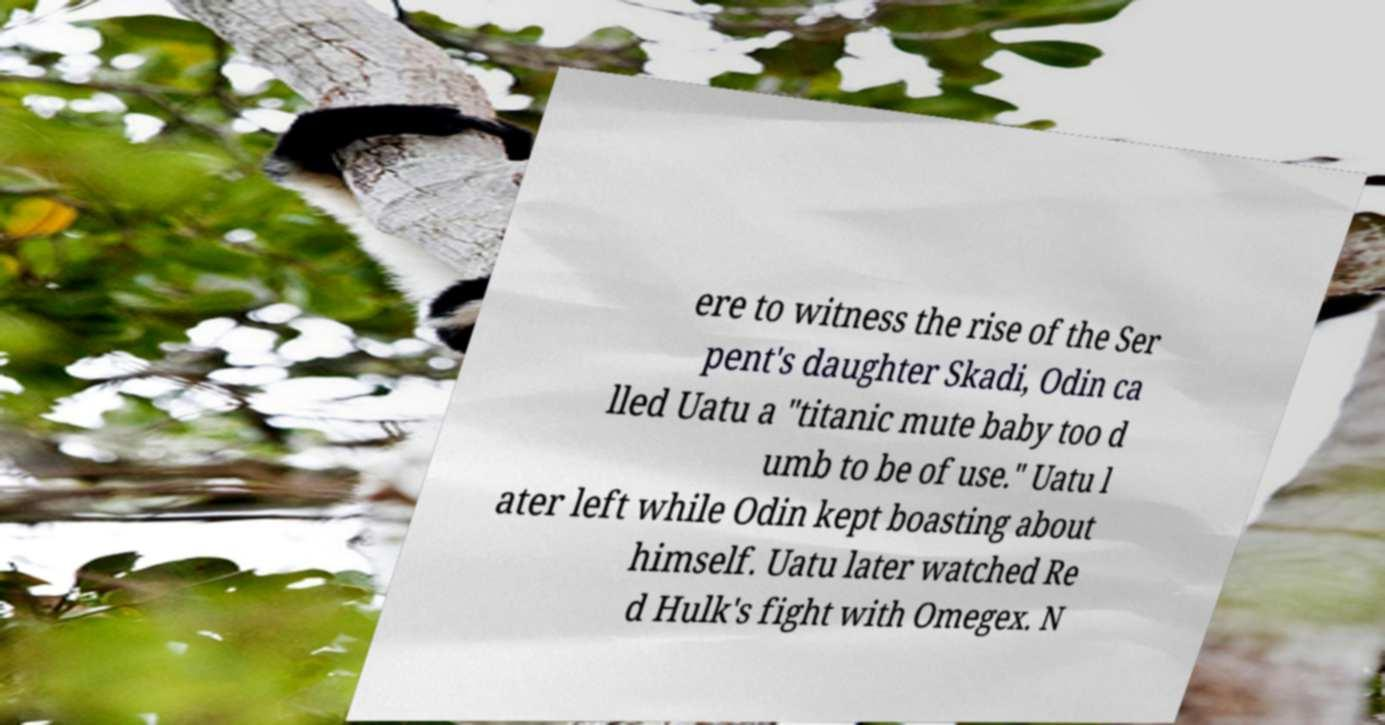What messages or text are displayed in this image? I need them in a readable, typed format. ere to witness the rise of the Ser pent's daughter Skadi, Odin ca lled Uatu a "titanic mute baby too d umb to be of use." Uatu l ater left while Odin kept boasting about himself. Uatu later watched Re d Hulk's fight with Omegex. N 